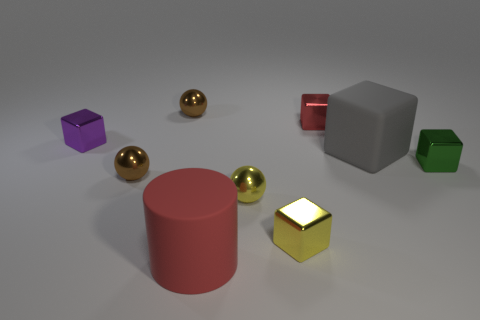There is a yellow shiny thing that is the same shape as the big gray matte thing; what is its size?
Your answer should be compact. Small. What number of rubber objects are left of the red object right of the cylinder that is in front of the tiny green shiny object?
Provide a short and direct response. 1. What is the color of the small cube that is to the left of the tiny brown metal sphere in front of the tiny red shiny object?
Provide a succinct answer. Purple. How many other objects are there of the same material as the gray block?
Provide a short and direct response. 1. There is a rubber cylinder that is to the left of the green metal object; how many small red things are on the left side of it?
Give a very brief answer. 0. Is there anything else that is the same shape as the green object?
Give a very brief answer. Yes. Is the color of the large rubber object that is on the right side of the small yellow metallic sphere the same as the sphere behind the tiny red metallic block?
Ensure brevity in your answer.  No. Is the number of large yellow balls less than the number of large blocks?
Provide a short and direct response. Yes. What shape is the large rubber thing that is behind the large object left of the big matte block?
Your response must be concise. Cube. Are there any other things that have the same size as the purple cube?
Your response must be concise. Yes. 